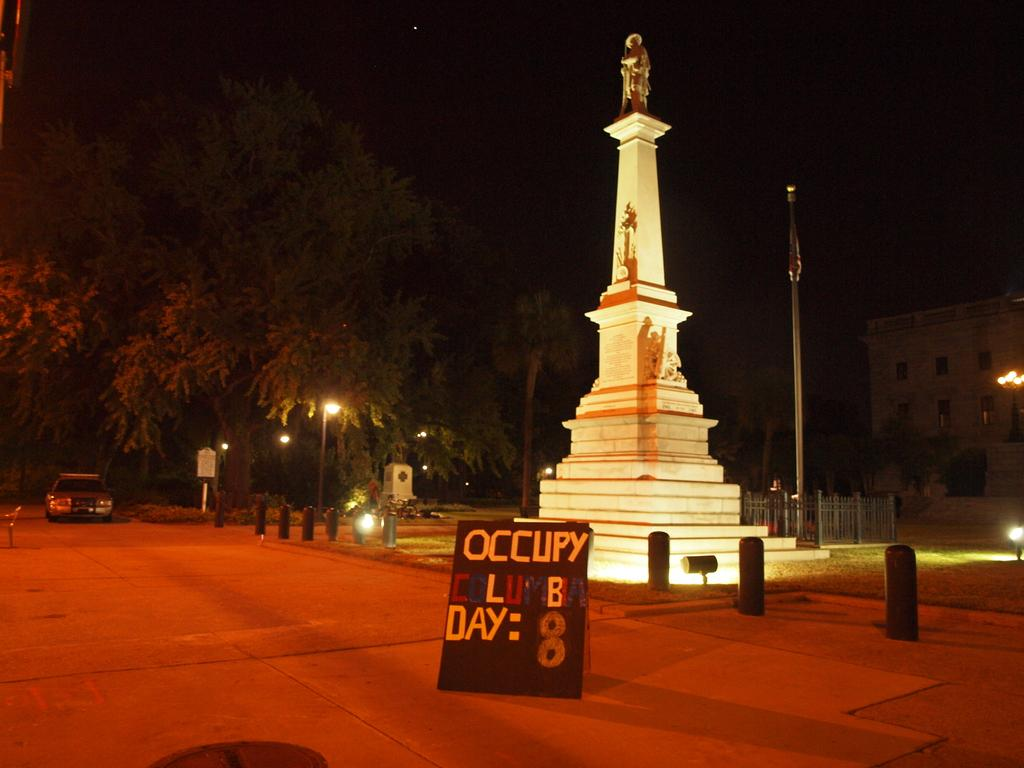Provide a one-sentence caption for the provided image. An occupy protester sign is placed in front of a large, well lit and narrow statue. 